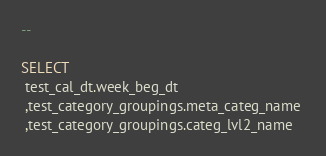Convert code to text. <code><loc_0><loc_0><loc_500><loc_500><_SQL_>--

SELECT 
 test_cal_dt.week_beg_dt 
 ,test_category_groupings.meta_categ_name 
 ,test_category_groupings.categ_lvl2_name </code> 